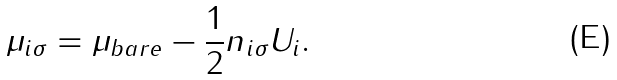Convert formula to latex. <formula><loc_0><loc_0><loc_500><loc_500>\mu _ { i \sigma } = \mu _ { b a r e } - \frac { 1 } { 2 } n _ { i \sigma } U _ { i } .</formula> 